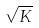<formula> <loc_0><loc_0><loc_500><loc_500>\sqrt { K }</formula> 